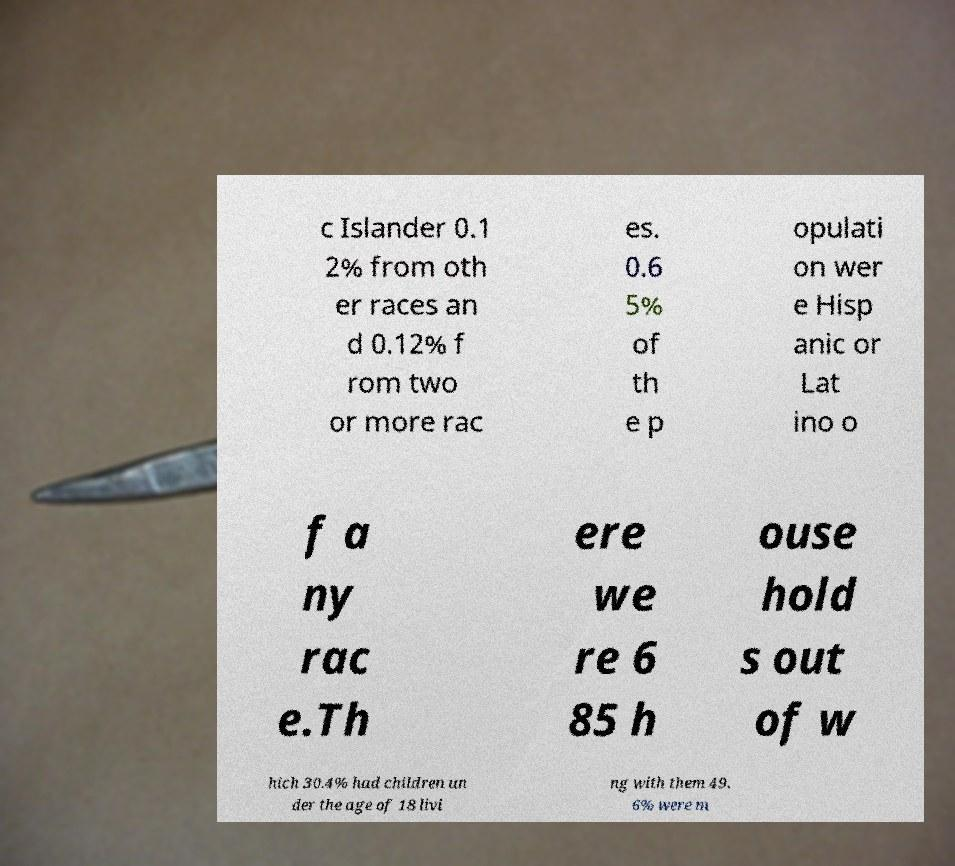Please identify and transcribe the text found in this image. c Islander 0.1 2% from oth er races an d 0.12% f rom two or more rac es. 0.6 5% of th e p opulati on wer e Hisp anic or Lat ino o f a ny rac e.Th ere we re 6 85 h ouse hold s out of w hich 30.4% had children un der the age of 18 livi ng with them 49. 6% were m 